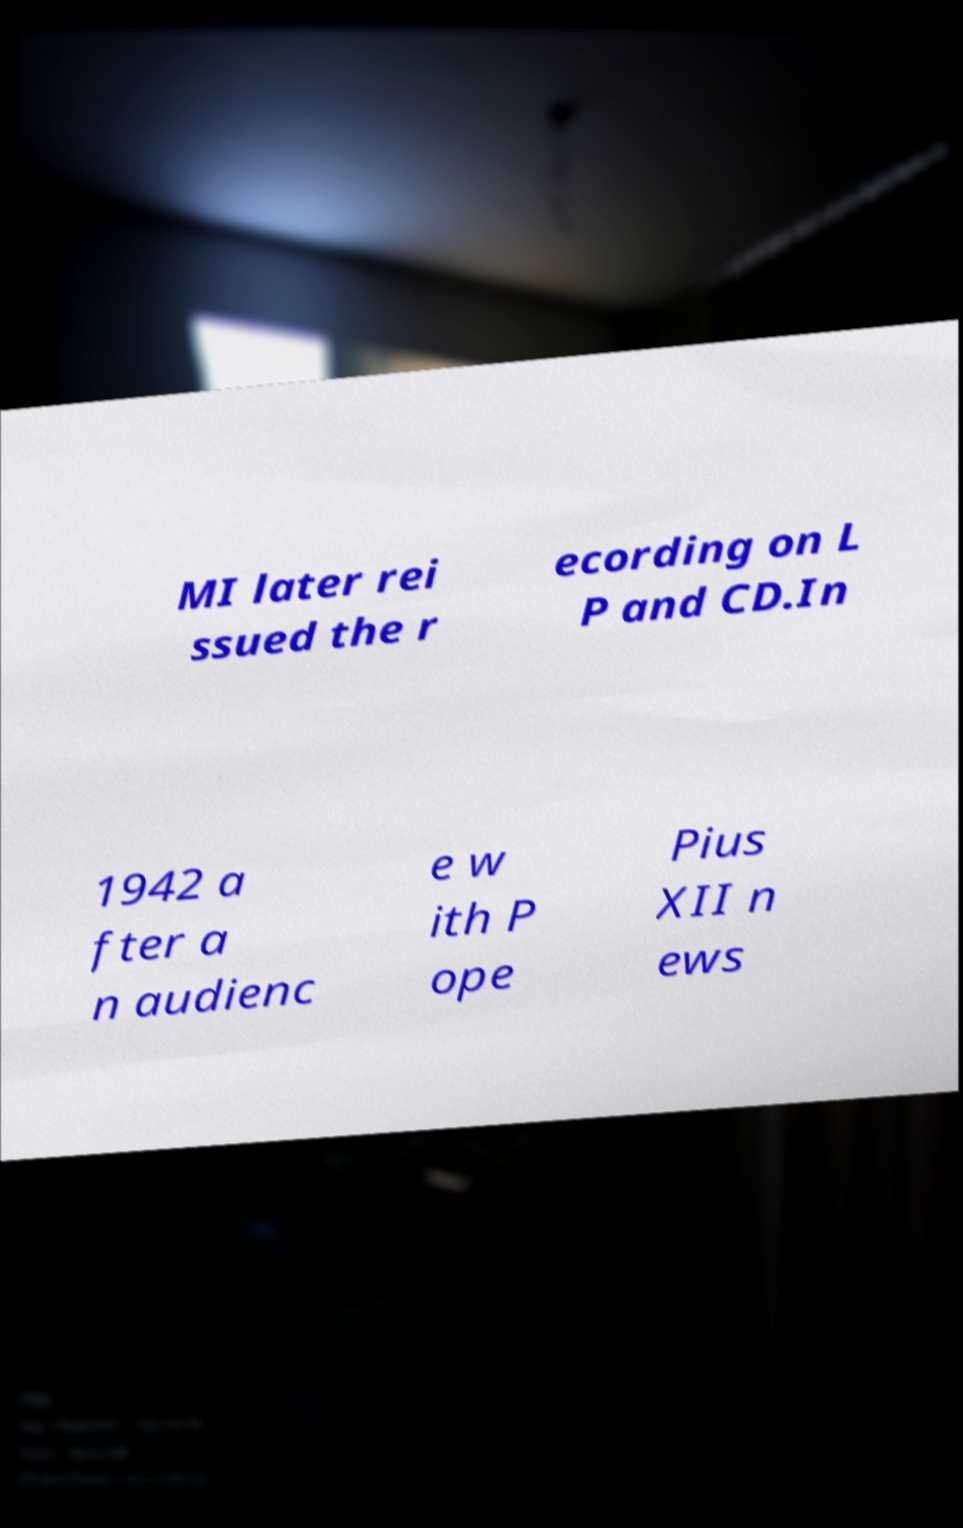Can you read and provide the text displayed in the image?This photo seems to have some interesting text. Can you extract and type it out for me? MI later rei ssued the r ecording on L P and CD.In 1942 a fter a n audienc e w ith P ope Pius XII n ews 